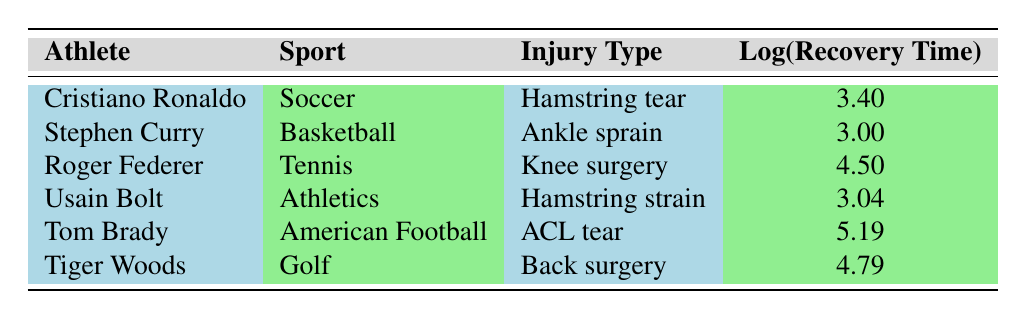What is the recovery time for Tom Brady's injury? The table shows Tom Brady's recovery time for his ACL tear injury as 180 days.
Answer: 180 days Who among these athletes has the longest recovery time? Tom Brady has the longest recovery time of 180 days due to an ACL tear, compared to other athletes in the table.
Answer: Tom Brady What is the logarithmic value of Roger Federer's recovery time? The table provides the logarithmic value of Roger Federer's recovery time as 4.50.
Answer: 4.50 Which sport has an athlete with a recovery time of exactly 30 days? Cristiano Ronaldo's injury in soccer results in a recovery time of exactly 30 days, as stated in the table.
Answer: Soccer Is it true that Usain Bolt’s injury recovery time is less than 25 days? The table indicates Usain Bolt's recovery time is 21 days, which is indeed less than 25 days.
Answer: Yes What is the difference in recovery time between Tom Brady and Stephen Curry? Tom Brady has a recovery time of 180 days and Stephen Curry has 20 days. The difference is 180 - 20 = 160 days.
Answer: 160 days What is the average recovery time of the athletes listed? To calculate the average, first sum all recovery times: 30 + 20 + 90 + 21 + 180 + 120 = 461 days. There are 6 athletes, so the average is 461 / 6 ≈ 76.83 days.
Answer: 76.83 days Which athlete has the shortest recovery time and what is it? Stephen Curry has the shortest recovery time of 20 days due to an ankle sprain, as shown in the table.
Answer: 20 days Are there more athletes with recovery times over 100 days? The table shows two athletes with recovery times over 100 days: Tom Brady (180 days) and Tiger Woods (120 days). Therefore, the answer is yes.
Answer: Yes 